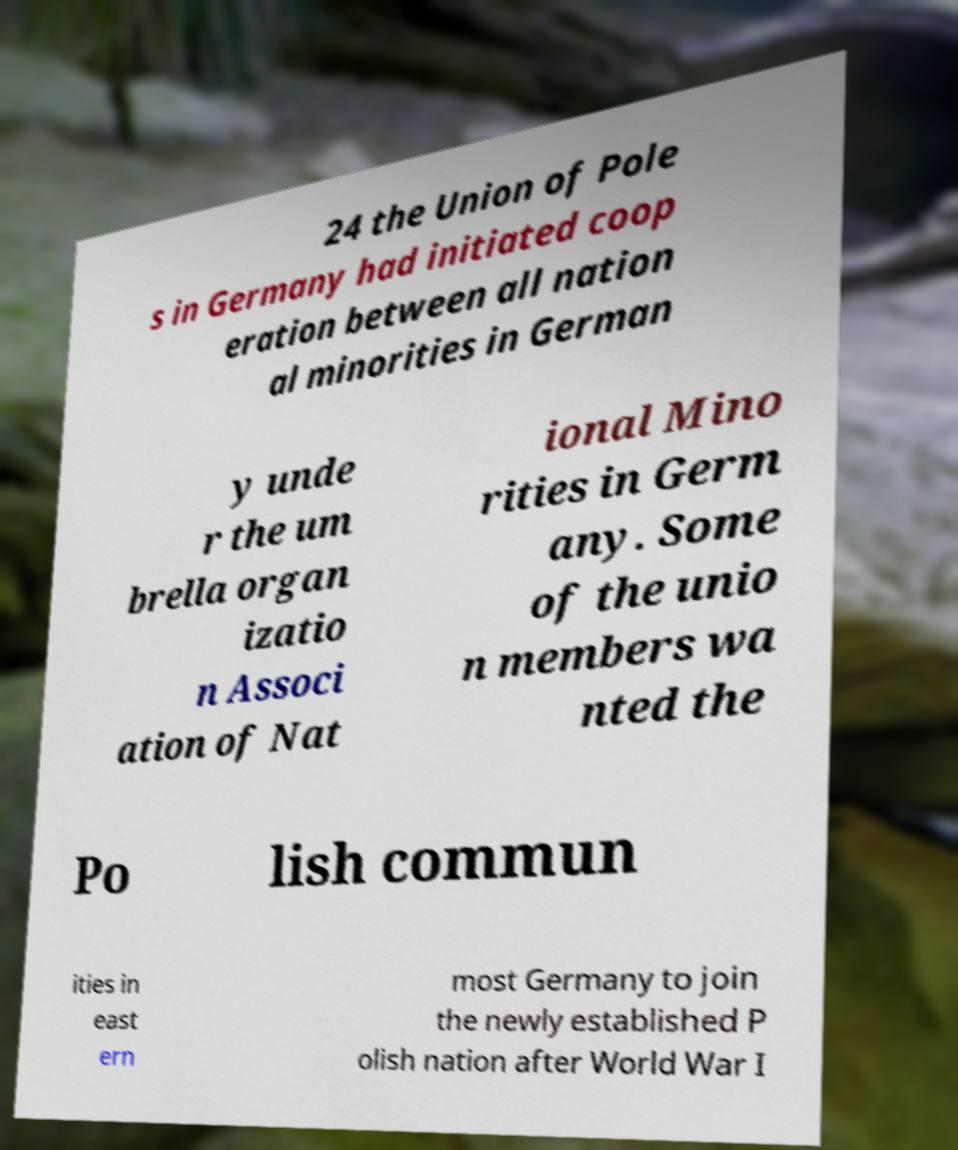Can you accurately transcribe the text from the provided image for me? 24 the Union of Pole s in Germany had initiated coop eration between all nation al minorities in German y unde r the um brella organ izatio n Associ ation of Nat ional Mino rities in Germ any. Some of the unio n members wa nted the Po lish commun ities in east ern most Germany to join the newly established P olish nation after World War I 